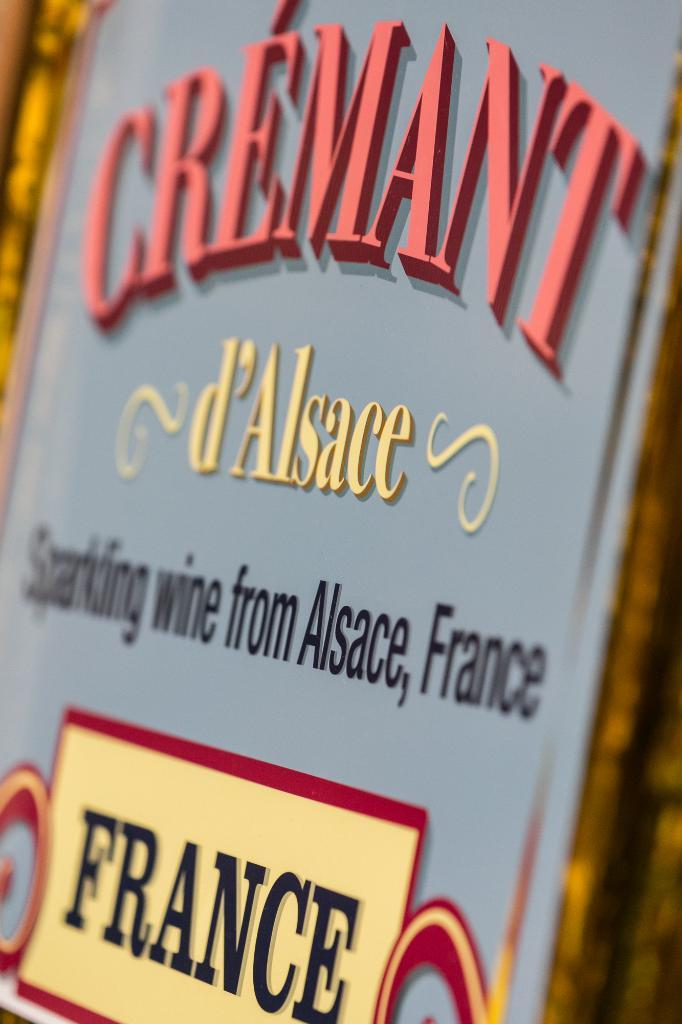<image>
Provide a brief description of the given image. book cover about the country of france alsace 